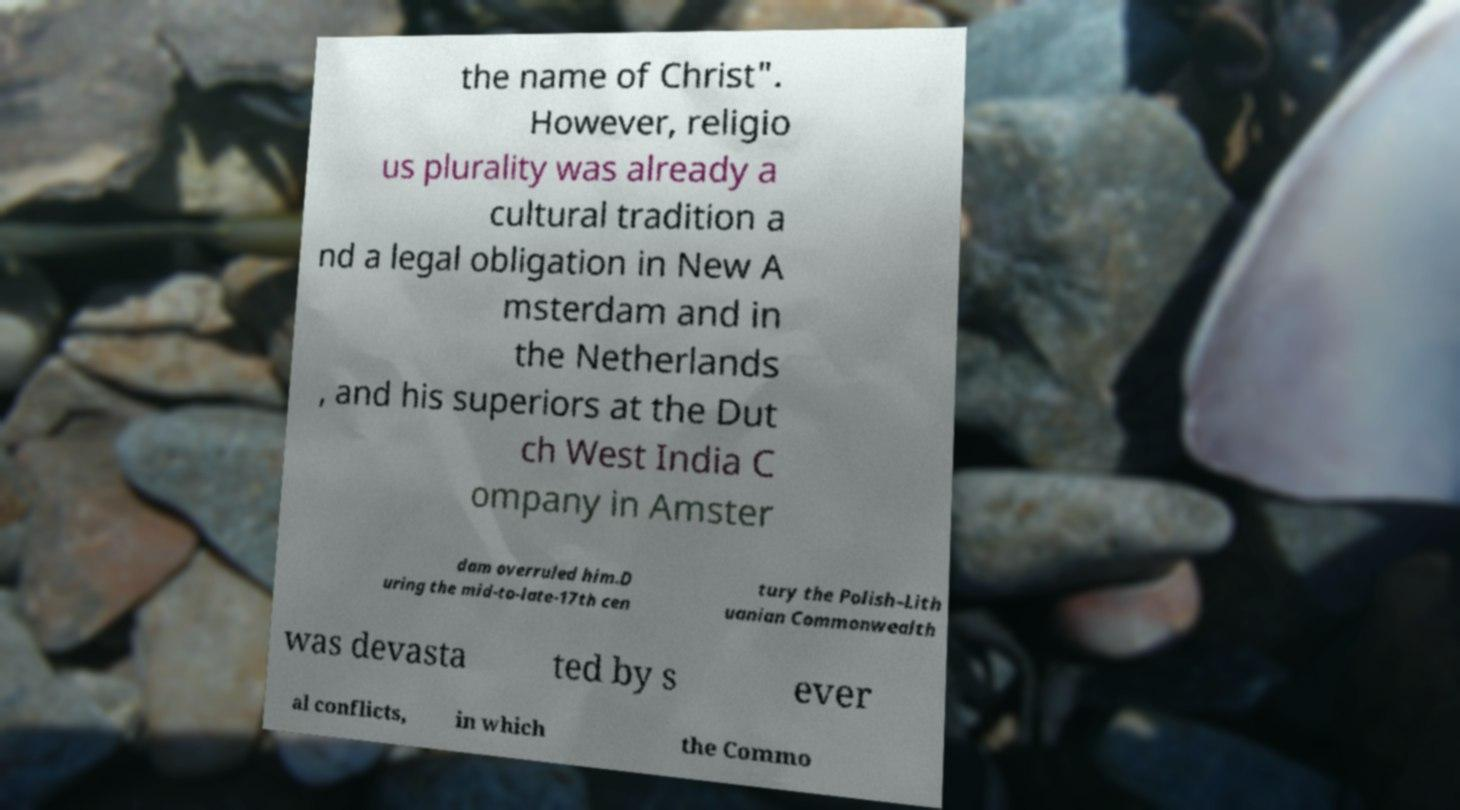Can you read and provide the text displayed in the image?This photo seems to have some interesting text. Can you extract and type it out for me? the name of Christ". However, religio us plurality was already a cultural tradition a nd a legal obligation in New A msterdam and in the Netherlands , and his superiors at the Dut ch West India C ompany in Amster dam overruled him.D uring the mid-to-late-17th cen tury the Polish–Lith uanian Commonwealth was devasta ted by s ever al conflicts, in which the Commo 